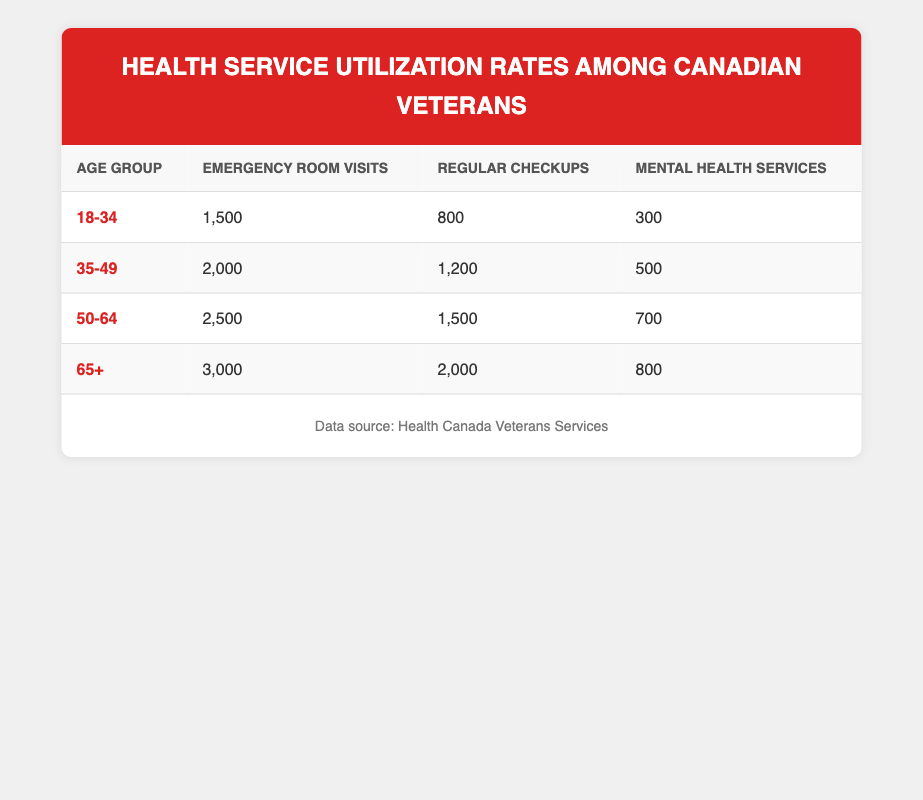What is the number of emergency room visits for veterans aged 18-34? The table indicates that there are 1,500 emergency room visits for veterans in the age group of 18-34.
Answer: 1,500 Which age group has the highest number of regular checkups? By examining the table, we see that the age group 65+ has 2,000 regular checkups, which is more than any other group listed.
Answer: 65+ What is the total number of mental health services utilized by veterans aged 35-49 and 50-64 combined? According to the table, veterans aged 35-49 utilized 500 mental health services, and those aged 50-64 used 700, so the total is 500 + 700 = 1,200.
Answer: 1,200 Is the number of emergency room visits for the age group 50-64 greater than that for the age group 18-34? Yes, veterans aged 50-64 had 2,500 emergency room visits, which is greater than the 1,500 visits in the 18-34 age group.
Answer: Yes What is the average number of regular checkups across all age groups? To find the average, we sum the regular checkups: 800 (18-34) + 1,200 (35-49) + 1,500 (50-64) + 2,000 (65+) = 5,500. There are four age groups, so the average is 5,500 / 4 = 1,375.
Answer: 1,375 Are there more emergency room visits in the 65+ age group than in the 35-49 age group? Yes, the 65+ group has 3,000 emergency room visits, which is greater than the 2,000 visits in the 35-49 age group.
Answer: Yes What is the difference in the number of mental health services utilized between the 65+ and 50-64 age groups? The 65+ age group utilized 800 mental health services and the 50-64 age group used 700. The difference is 800 - 700 = 100.
Answer: 100 How many total emergency room visits were there across all age groups? By summing the emergency room visits across all age groups: 1,500 + 2,000 + 2,500 + 3,000 = 9,000.
Answer: 9,000 